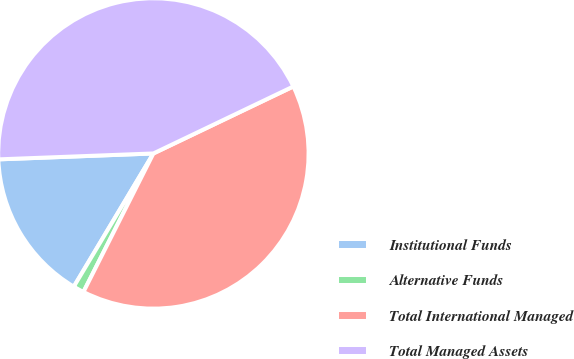Convert chart to OTSL. <chart><loc_0><loc_0><loc_500><loc_500><pie_chart><fcel>Institutional Funds<fcel>Alternative Funds<fcel>Total International Managed<fcel>Total Managed Assets<nl><fcel>15.82%<fcel>1.13%<fcel>39.55%<fcel>43.5%<nl></chart> 